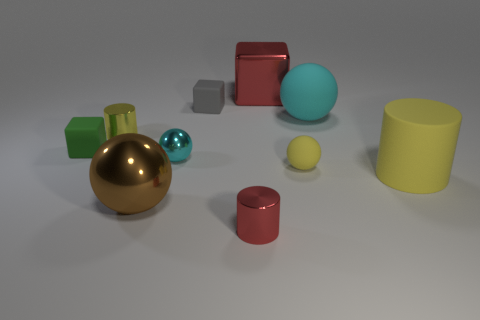Subtract all blocks. How many objects are left? 7 Add 2 metallic blocks. How many metallic blocks are left? 3 Add 5 metallic objects. How many metallic objects exist? 10 Subtract 0 brown cylinders. How many objects are left? 10 Subtract all big green matte cylinders. Subtract all tiny cyan shiny objects. How many objects are left? 9 